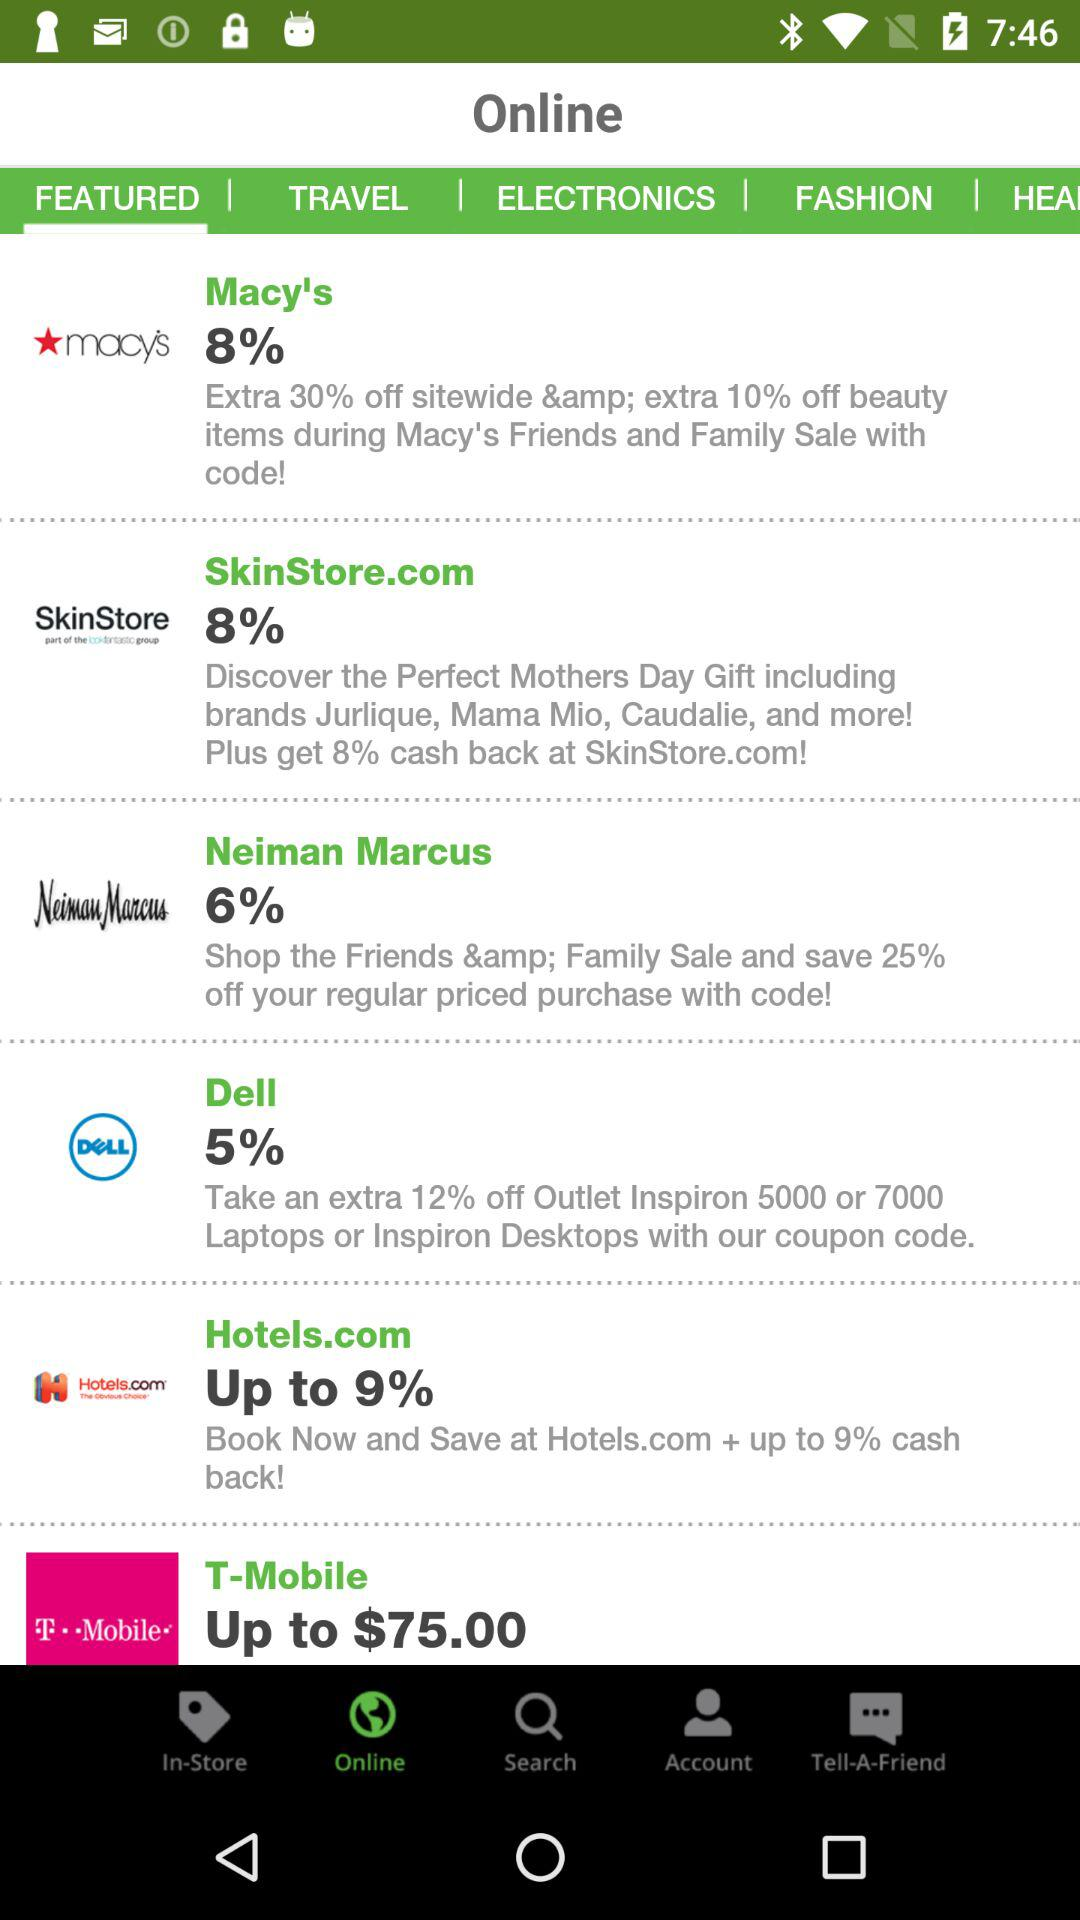How many of the coupons have an 8% discount?
Answer the question using a single word or phrase. 2 